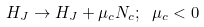Convert formula to latex. <formula><loc_0><loc_0><loc_500><loc_500>H _ { J } \rightarrow H _ { J } + \mu _ { c } N _ { c } ; \ \mu _ { c } < 0</formula> 